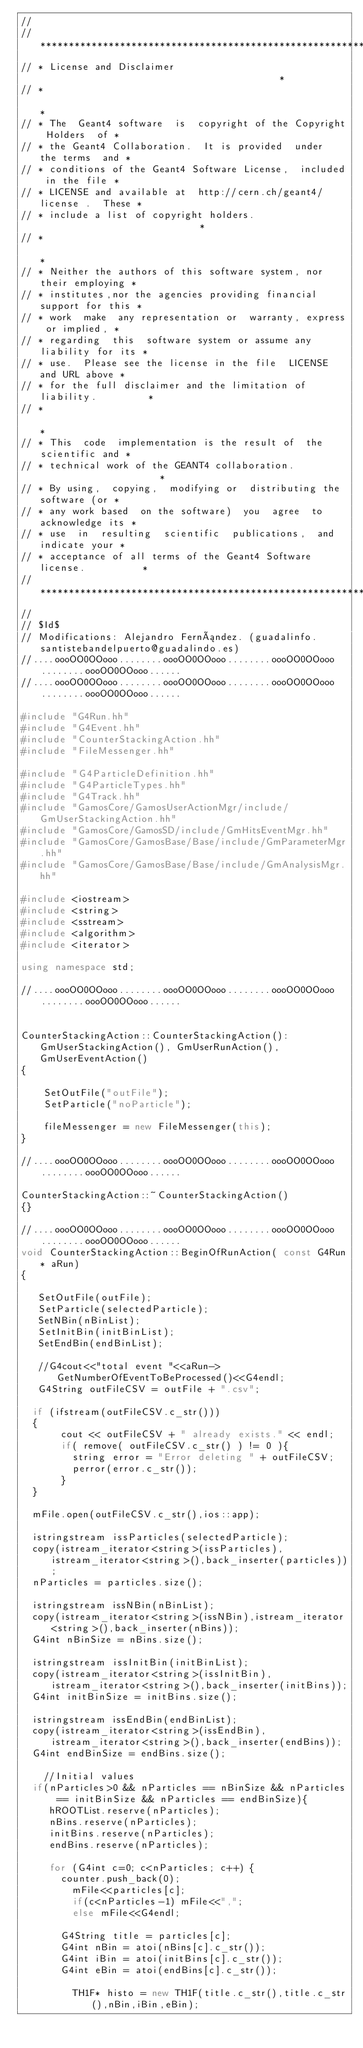<code> <loc_0><loc_0><loc_500><loc_500><_C++_>//
// ********************************************************************
// * License and Disclaimer                                           *
// *                                                                  *
// * The  Geant4 software  is  copyright of the Copyright Holders  of *
// * the Geant4 Collaboration.  It is provided  under  the terms  and *
// * conditions of the Geant4 Software License,  included in the file *
// * LICENSE and available at  http://cern.ch/geant4/license .  These *
// * include a list of copyright holders.                             *
// *                                                                  *
// * Neither the authors of this software system, nor their employing *
// * institutes,nor the agencies providing financial support for this *
// * work  make  any representation or  warranty, express or implied, *
// * regarding  this  software system or assume any liability for its *
// * use.  Please see the license in the file  LICENSE  and URL above *
// * for the full disclaimer and the limitation of liability.         *
// *                                                                  *
// * This  code  implementation is the result of  the  scientific and *
// * technical work of the GEANT4 collaboration.                      *
// * By using,  copying,  modifying or  distributing the software (or *
// * any work based  on the software)  you  agree  to acknowledge its *
// * use  in  resulting  scientific  publications,  and indicate your *
// * acceptance of all terms of the Geant4 Software license.          *
// ********************************************************************
//
// $Id$
// Modifications: Alejandro Fernández. (guadalinfo.santistebandelpuerto@guadalindo.es)
//....oooOO0OOooo........oooOO0OOooo........oooOO0OOooo........oooOO0OOooo......
//....oooOO0OOooo........oooOO0OOooo........oooOO0OOooo........oooOO0OOooo......

#include "G4Run.hh"
#include "G4Event.hh"
#include "CounterStackingAction.hh"
#include "FileMessenger.hh"

#include "G4ParticleDefinition.hh"
#include "G4ParticleTypes.hh"
#include "G4Track.hh"
#include "GamosCore/GamosUserActionMgr/include/GmUserStackingAction.hh"
#include "GamosCore/GamosSD/include/GmHitsEventMgr.hh"
#include "GamosCore/GamosBase/Base/include/GmParameterMgr.hh"
#include "GamosCore/GamosBase/Base/include/GmAnalysisMgr.hh"

#include <iostream>
#include <string>
#include <sstream>
#include <algorithm>
#include <iterator>

using namespace std;

//....oooOO0OOooo........oooOO0OOooo........oooOO0OOooo........oooOO0OOooo......


CounterStackingAction::CounterStackingAction(): GmUserStackingAction(), GmUserRunAction(), GmUserEventAction()
{

    SetOutFile("outFile");
    SetParticle("noParticle");
    
    fileMessenger = new FileMessenger(this);
}

//....oooOO0OOooo........oooOO0OOooo........oooOO0OOooo........oooOO0OOooo......

CounterStackingAction::~CounterStackingAction()
{}

//....oooOO0OOooo........oooOO0OOooo........oooOO0OOooo........oooOO0OOooo......
void CounterStackingAction::BeginOfRunAction( const G4Run* aRun)
{

   SetOutFile(outFile);
   SetParticle(selectedParticle);
   SetNBin(nBinList);
   SetInitBin(initBinList);
   SetEndBin(endBinList);

   //G4cout<<"total event "<<aRun->GetNumberOfEventToBeProcessed()<<G4endl;
   G4String outFileCSV = outFile + ".csv";
	
	if (ifstream(outFileCSV.c_str()))
	{
	     cout << outFileCSV + " already exists." << endl;
	     if( remove( outFileCSV.c_str() ) != 0 ){
	    	 string error = "Error deleting " + outFileCSV;
	    	 perror(error.c_str());
	     }
	}
	
	mFile.open(outFileCSV.c_str(),ios::app);
   
	istringstream issParticles(selectedParticle);
	copy(istream_iterator<string>(issParticles),istream_iterator<string>(),back_inserter(particles));
	nParticles = particles.size();

	istringstream issNBin(nBinList);
	copy(istream_iterator<string>(issNBin),istream_iterator<string>(),back_inserter(nBins));
	G4int nBinSize = nBins.size();
	
	istringstream issInitBin(initBinList);
	copy(istream_iterator<string>(issInitBin),istream_iterator<string>(),back_inserter(initBins));
	G4int initBinSize = initBins.size();
	
	istringstream issEndBin(endBinList);
	copy(istream_iterator<string>(issEndBin),istream_iterator<string>(),back_inserter(endBins));
	G4int endBinSize = endBins.size();

    //Initial values
	if(nParticles>0 && nParticles == nBinSize && nParticles == initBinSize && nParticles == endBinSize){
	   hROOTList.reserve(nParticles);
	   nBins.reserve(nParticles);
	   initBins.reserve(nParticles);
	   endBins.reserve(nParticles);

	   for (G4int c=0; c<nParticles; c++) {
		   counter.push_back(0);
	   	   mFile<<particles[c];
	   	   if(c<nParticles-1) mFile<<",";
	   	   else mFile<<G4endl;
			
		   G4String title = particles[c];
		   G4int nBin = atoi(nBins[c].c_str());
		   G4int iBin = atoi(initBins[c].c_str());
		   G4int eBin = atoi(endBins[c].c_str());
		   
	       TH1F* histo = new TH1F(title.c_str(),title.c_str(),nBin,iBin,eBin);</code> 